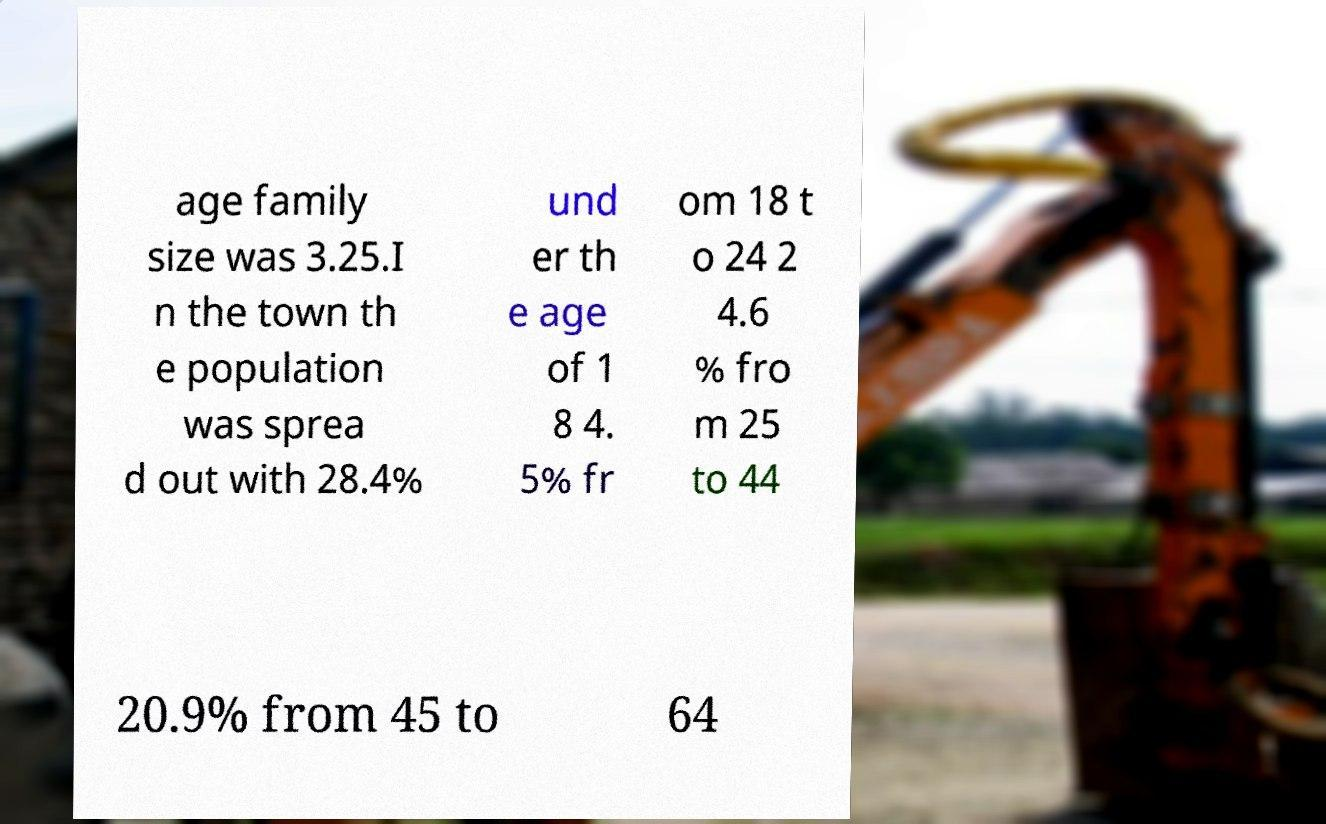Can you read and provide the text displayed in the image?This photo seems to have some interesting text. Can you extract and type it out for me? age family size was 3.25.I n the town th e population was sprea d out with 28.4% und er th e age of 1 8 4. 5% fr om 18 t o 24 2 4.6 % fro m 25 to 44 20.9% from 45 to 64 